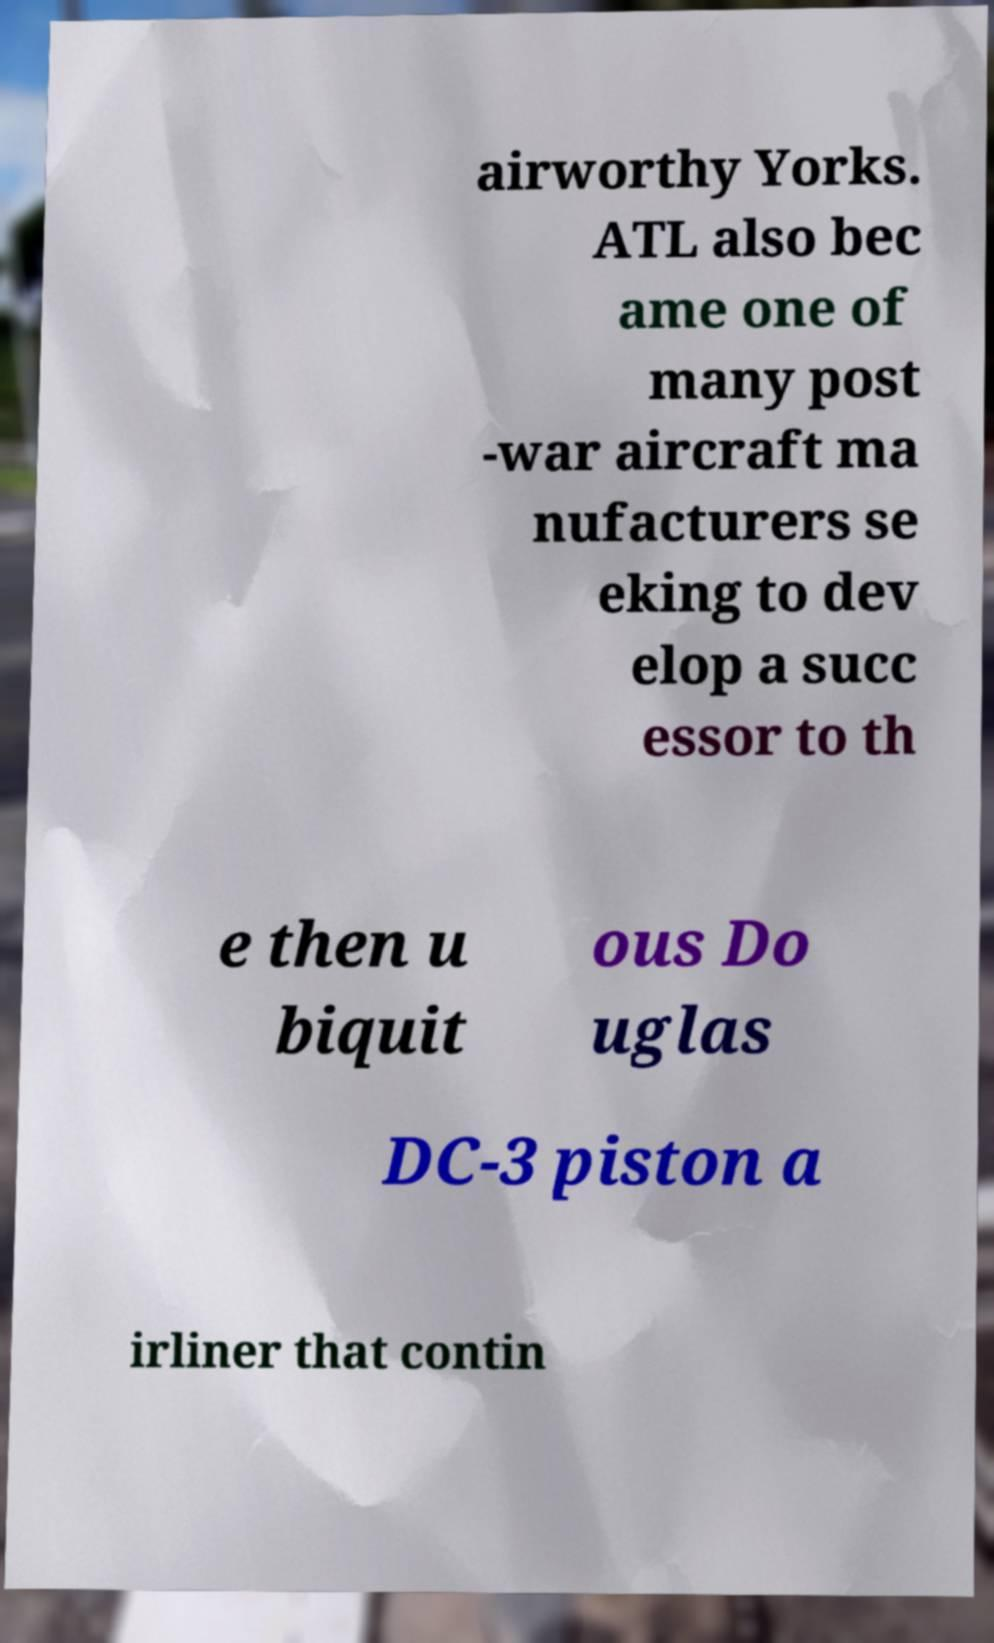Can you read and provide the text displayed in the image?This photo seems to have some interesting text. Can you extract and type it out for me? airworthy Yorks. ATL also bec ame one of many post -war aircraft ma nufacturers se eking to dev elop a succ essor to th e then u biquit ous Do uglas DC-3 piston a irliner that contin 